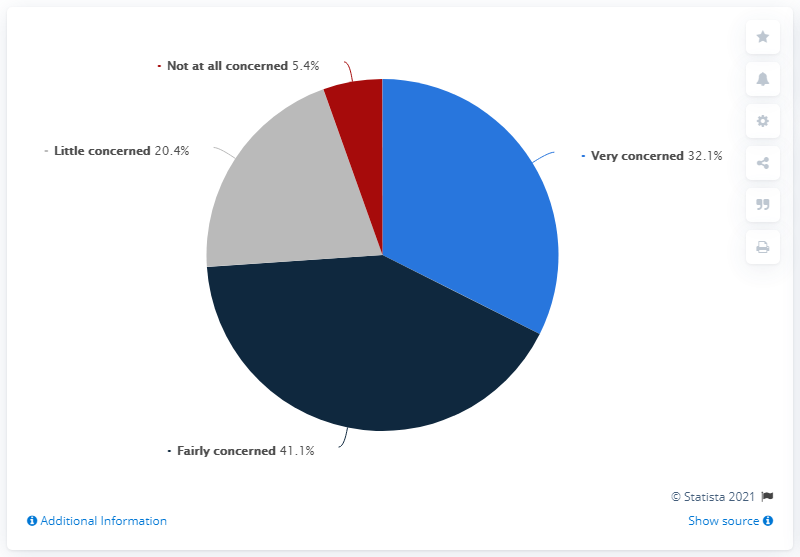Identify some key points in this picture. According to a survey conducted in Italy as of February 21, 2020, 5.4% of the population stated that they were not worried about COVID-19. According to a recent survey, 32.1% of Italians reported being very concerned about COVID-19. The most popular response is 'fairly concerned'," declares the speaker. The sum of attitudes that show little concern is 20.4. 